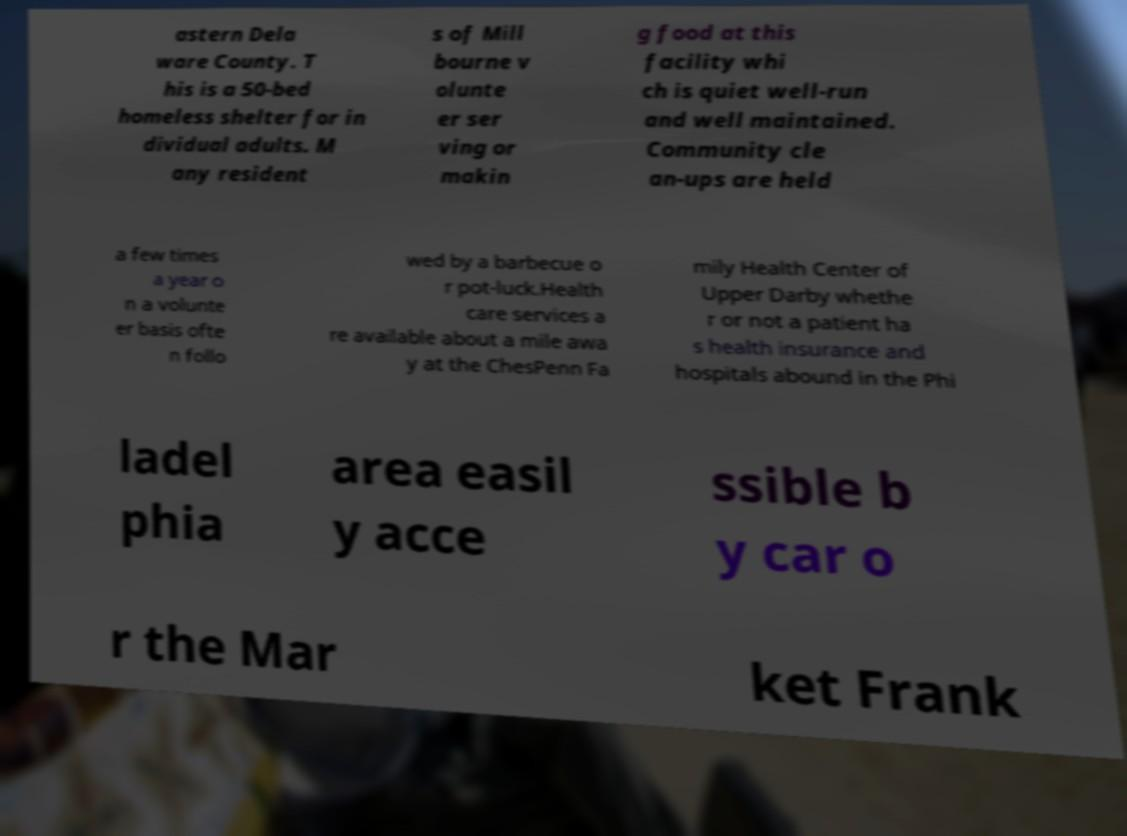For documentation purposes, I need the text within this image transcribed. Could you provide that? astern Dela ware County. T his is a 50-bed homeless shelter for in dividual adults. M any resident s of Mill bourne v olunte er ser ving or makin g food at this facility whi ch is quiet well-run and well maintained. Community cle an-ups are held a few times a year o n a volunte er basis ofte n follo wed by a barbecue o r pot-luck.Health care services a re available about a mile awa y at the ChesPenn Fa mily Health Center of Upper Darby whethe r or not a patient ha s health insurance and hospitals abound in the Phi ladel phia area easil y acce ssible b y car o r the Mar ket Frank 